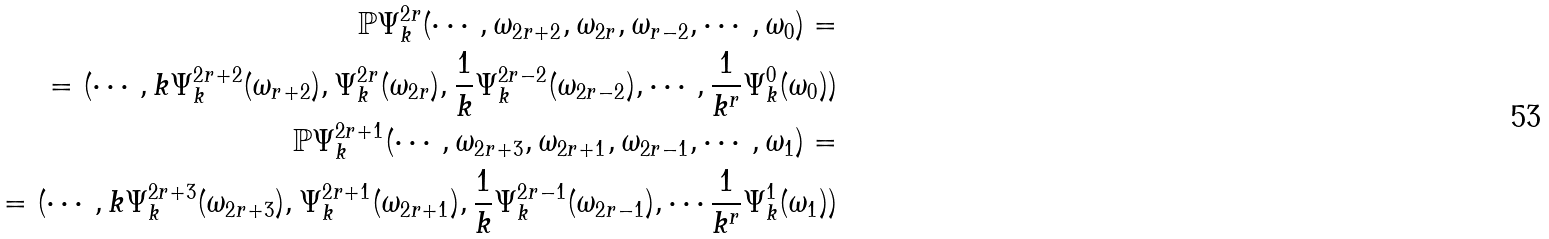Convert formula to latex. <formula><loc_0><loc_0><loc_500><loc_500>\mathbb { P } \Psi _ { k } ^ { 2 r } ( \cdots , \omega _ { 2 r + 2 } , \omega _ { 2 r } , \omega _ { r - 2 } , \cdots , \omega _ { 0 } ) = \\ = ( \cdots , k \Psi _ { k } ^ { 2 r + 2 } ( \omega _ { r + 2 } ) , \Psi _ { k } ^ { 2 r } ( \omega _ { 2 r } ) , \frac { 1 } { k } \Psi _ { k } ^ { 2 r - 2 } ( \omega _ { 2 r - 2 } ) , \cdots , \frac { 1 } { k ^ { r } } \Psi _ { k } ^ { 0 } ( \omega _ { 0 } ) ) \\ \mathbb { P } \Psi _ { k } ^ { 2 r + 1 } ( \cdots , \omega _ { 2 r + 3 } , \omega _ { 2 r + 1 } , \omega _ { 2 r - 1 } , \cdots , \omega _ { 1 } ) = \\ = ( \cdots , k \Psi _ { k } ^ { 2 r + 3 } ( \omega _ { 2 r + 3 } ) , \Psi _ { k } ^ { 2 r + 1 } ( \omega _ { 2 r + 1 } ) , \frac { 1 } { k } \Psi _ { k } ^ { 2 r - 1 } ( \omega _ { 2 r - 1 } ) , \cdots \frac { 1 } { k ^ { r } } \Psi _ { k } ^ { 1 } ( \omega _ { 1 } ) )</formula> 